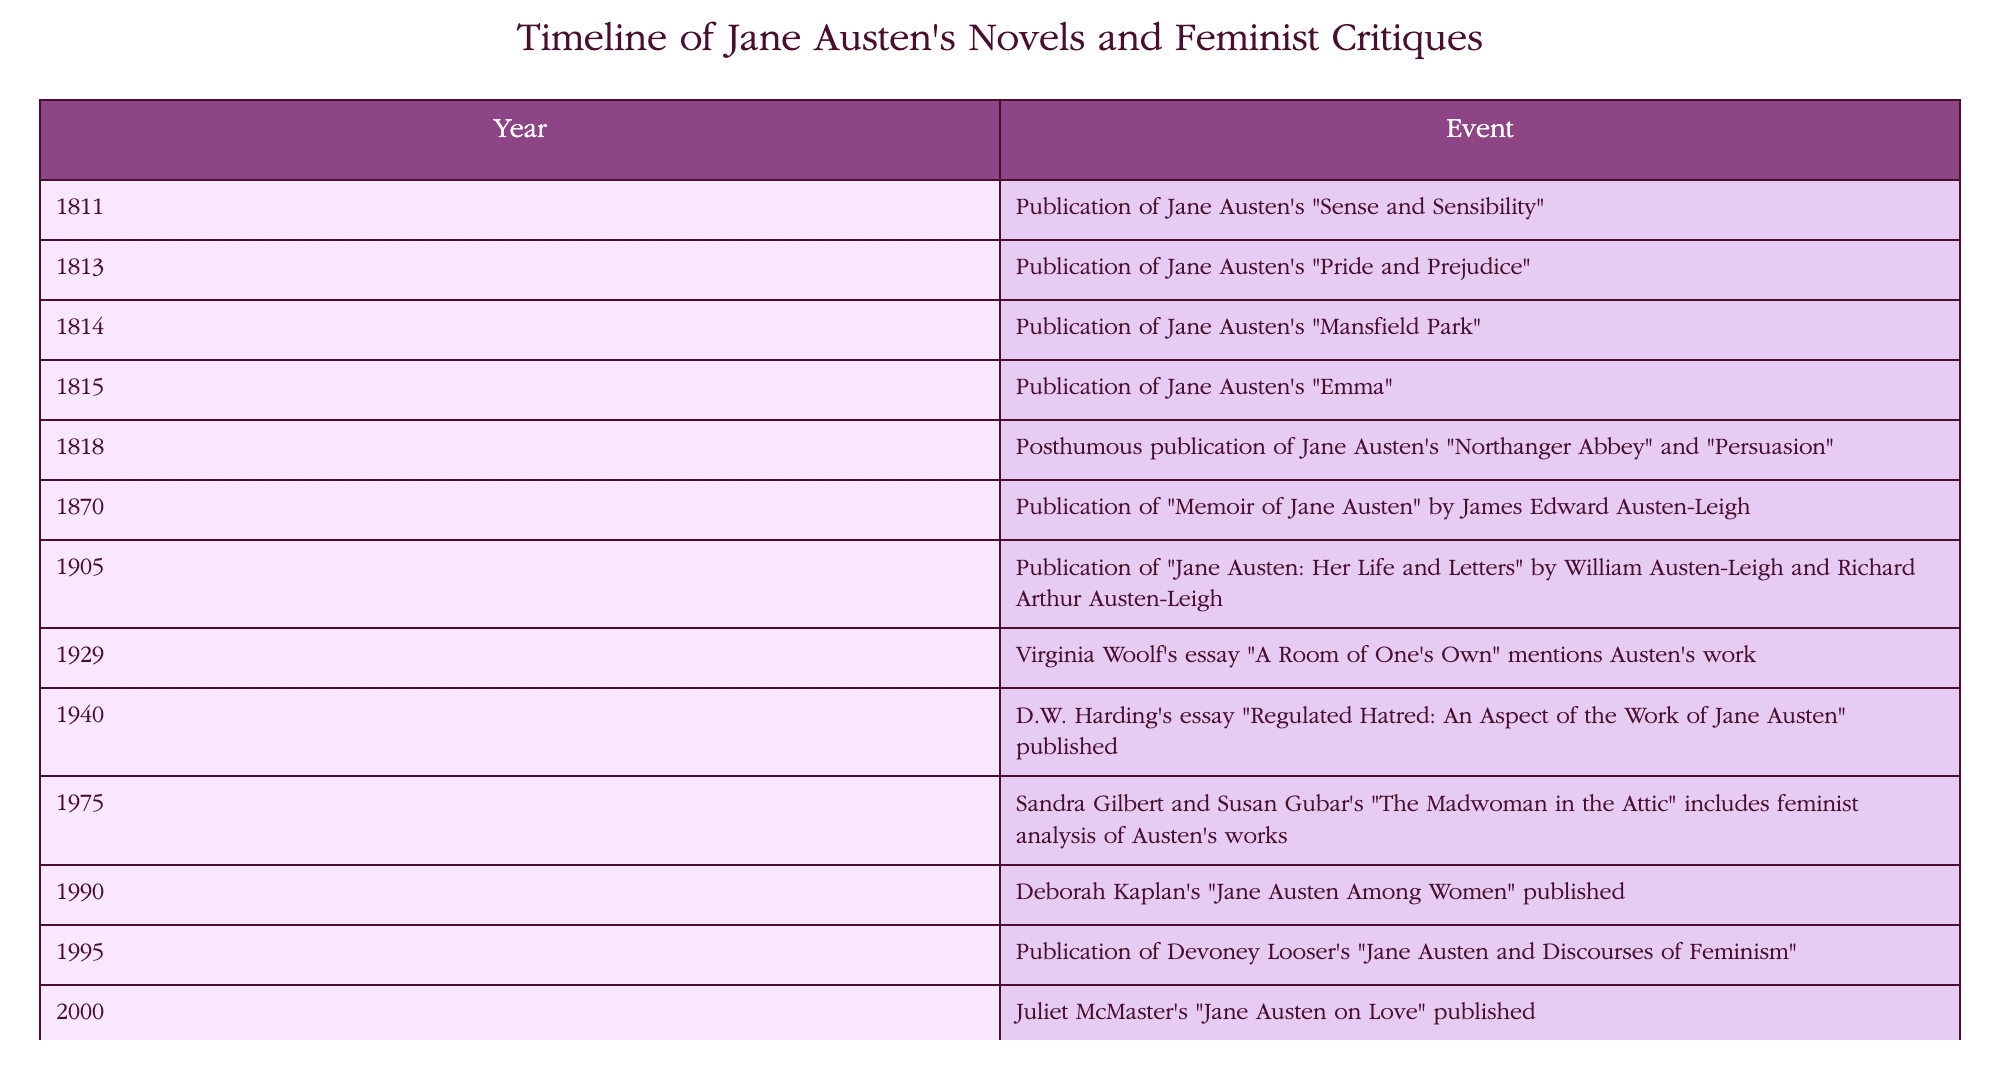What year was "Pride and Prejudice" published? "Pride and Prejudice" is listed under the year 1813 in the table, indicating that it was published in that year.
Answer: 1813 How many years passed between the publication of "Sense and Sensibility" and "Emma"? "Sense and Sensibility" was published in 1811 and "Emma" in 1815. Subtracting 1811 from 1815 gives 4 years.
Answer: 4 years Did James Edward Austen-Leigh publish anything related to Jane Austen before 1900? The table shows that "Memoir of Jane Austen" was published in 1870, which is before 1900, indicating that yes, he did publish something related to her before that year.
Answer: Yes Which feminist critique included Jane Austen's works in 1975? The table indicates that in 1975, "The Madwoman in the Attic" by Sandra Gilbert and Susan Gubar included feminist analysis of Austen's works.
Answer: "The Madwoman in the Attic" What is the period between the publication of the last of Austen's novels and the first feminist critique in the table? The last published novel in the table is "Persuasion" and "Northanger Abbey," which were published posthumously in 1818. The first feminist critique in the table is "The Madwoman in the Attic" published in 1975. Subtracting 1818 from 1975 gives 157 years.
Answer: 157 years What significant event related to Austen occurred in 1940? In 1940, D.W. Harding's essay "Regulated Hatred: An Aspect of the Work of Jane Austen" was published, marking a significant event in feminist critique related to her work.
Answer: Publication of Harding's essay How many publications related to Austen are listed before 2000? The publications listed before 2000 are from the years 1811, 1813, 1814, 1815, 1818, 1870, 1905, 1929, 1940, 1975, and 1990. Counting these gives a total of 11 publications.
Answer: 11 publications Which years saw the publication of works that are specifically critiques of Jane Austen's novels? The critiques of Austen's works are listed in the years 1940, 1975, 1990, 1995, 2000, 2004, 2010, and 2021. That totals 8 years.
Answer: 8 years Identify a notable change in authorship from novels to commentaries about Jane Austen's works. The novels were all authored by Jane Austen herself, whereas the commentaries from 1940 onwards are authored by various scholars, indicating a shift from author to commentator.
Answer: Shift in authorship 